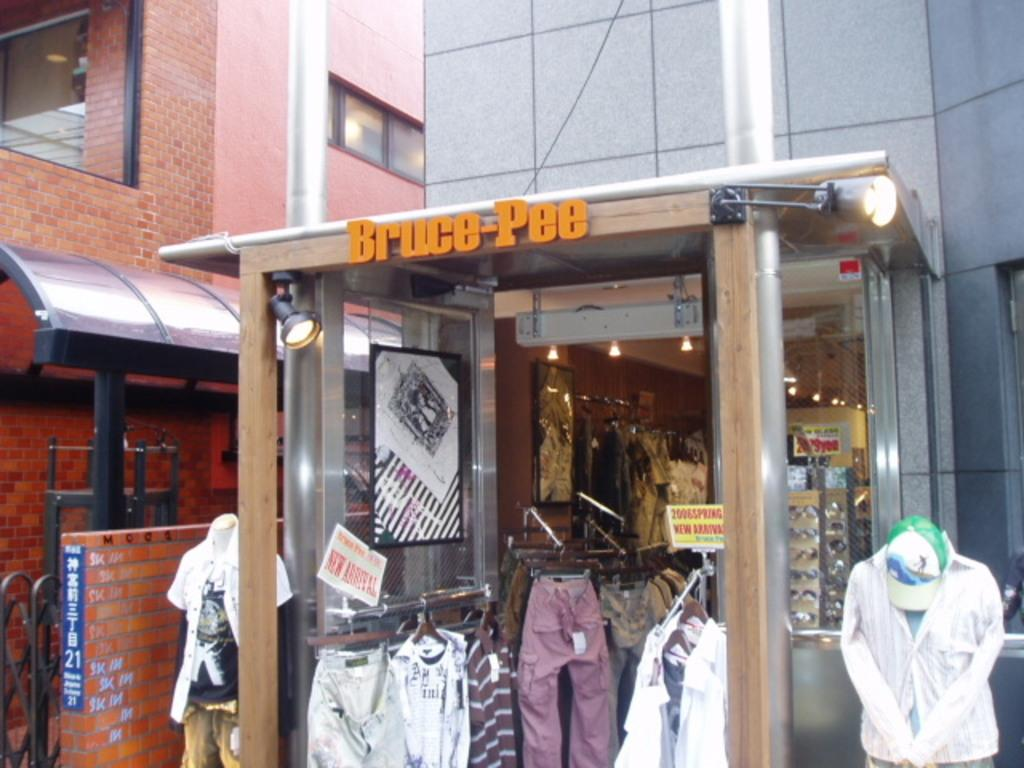<image>
Describe the image concisely. a store that is called Bruce Pee with many clothes 